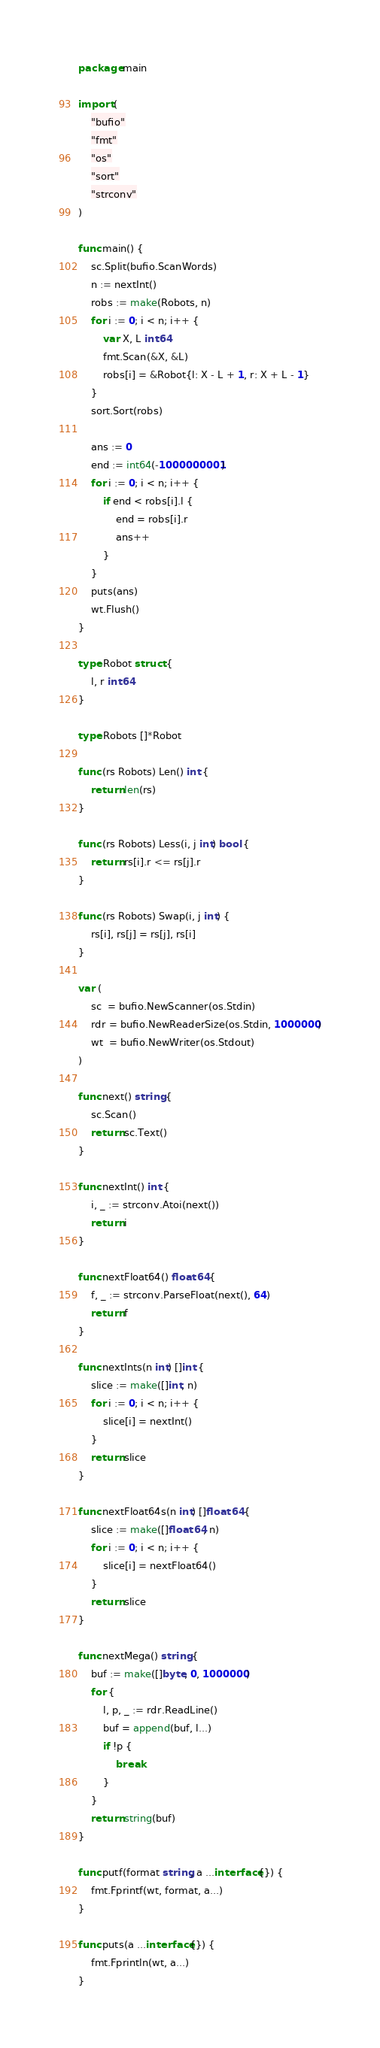<code> <loc_0><loc_0><loc_500><loc_500><_Go_>package main

import (
	"bufio"
	"fmt"
	"os"
	"sort"
	"strconv"
)

func main() {
	sc.Split(bufio.ScanWords)
	n := nextInt()
	robs := make(Robots, n)
	for i := 0; i < n; i++ {
		var X, L int64
		fmt.Scan(&X, &L)
		robs[i] = &Robot{l: X - L + 1, r: X + L - 1}
	}
	sort.Sort(robs)

	ans := 0
	end := int64(-1000000001)
	for i := 0; i < n; i++ {
		if end < robs[i].l {
			end = robs[i].r
			ans++
		}
	}
	puts(ans)
	wt.Flush()
}

type Robot struct {
	l, r int64
}

type Robots []*Robot

func (rs Robots) Len() int {
	return len(rs)
}

func (rs Robots) Less(i, j int) bool {
	return rs[i].r <= rs[j].r
}

func (rs Robots) Swap(i, j int) {
	rs[i], rs[j] = rs[j], rs[i]
}

var (
	sc  = bufio.NewScanner(os.Stdin)
	rdr = bufio.NewReaderSize(os.Stdin, 1000000)
	wt  = bufio.NewWriter(os.Stdout)
)

func next() string {
	sc.Scan()
	return sc.Text()
}

func nextInt() int {
	i, _ := strconv.Atoi(next())
	return i
}

func nextFloat64() float64 {
	f, _ := strconv.ParseFloat(next(), 64)
	return f
}

func nextInts(n int) []int {
	slice := make([]int, n)
	for i := 0; i < n; i++ {
		slice[i] = nextInt()
	}
	return slice
}

func nextFloat64s(n int) []float64 {
	slice := make([]float64, n)
	for i := 0; i < n; i++ {
		slice[i] = nextFloat64()
	}
	return slice
}

func nextMega() string {
	buf := make([]byte, 0, 1000000)
	for {
		l, p, _ := rdr.ReadLine()
		buf = append(buf, l...)
		if !p {
			break
		}
	}
	return string(buf)
}

func putf(format string, a ...interface{}) {
	fmt.Fprintf(wt, format, a...)
}

func puts(a ...interface{}) {
	fmt.Fprintln(wt, a...)
}
</code> 